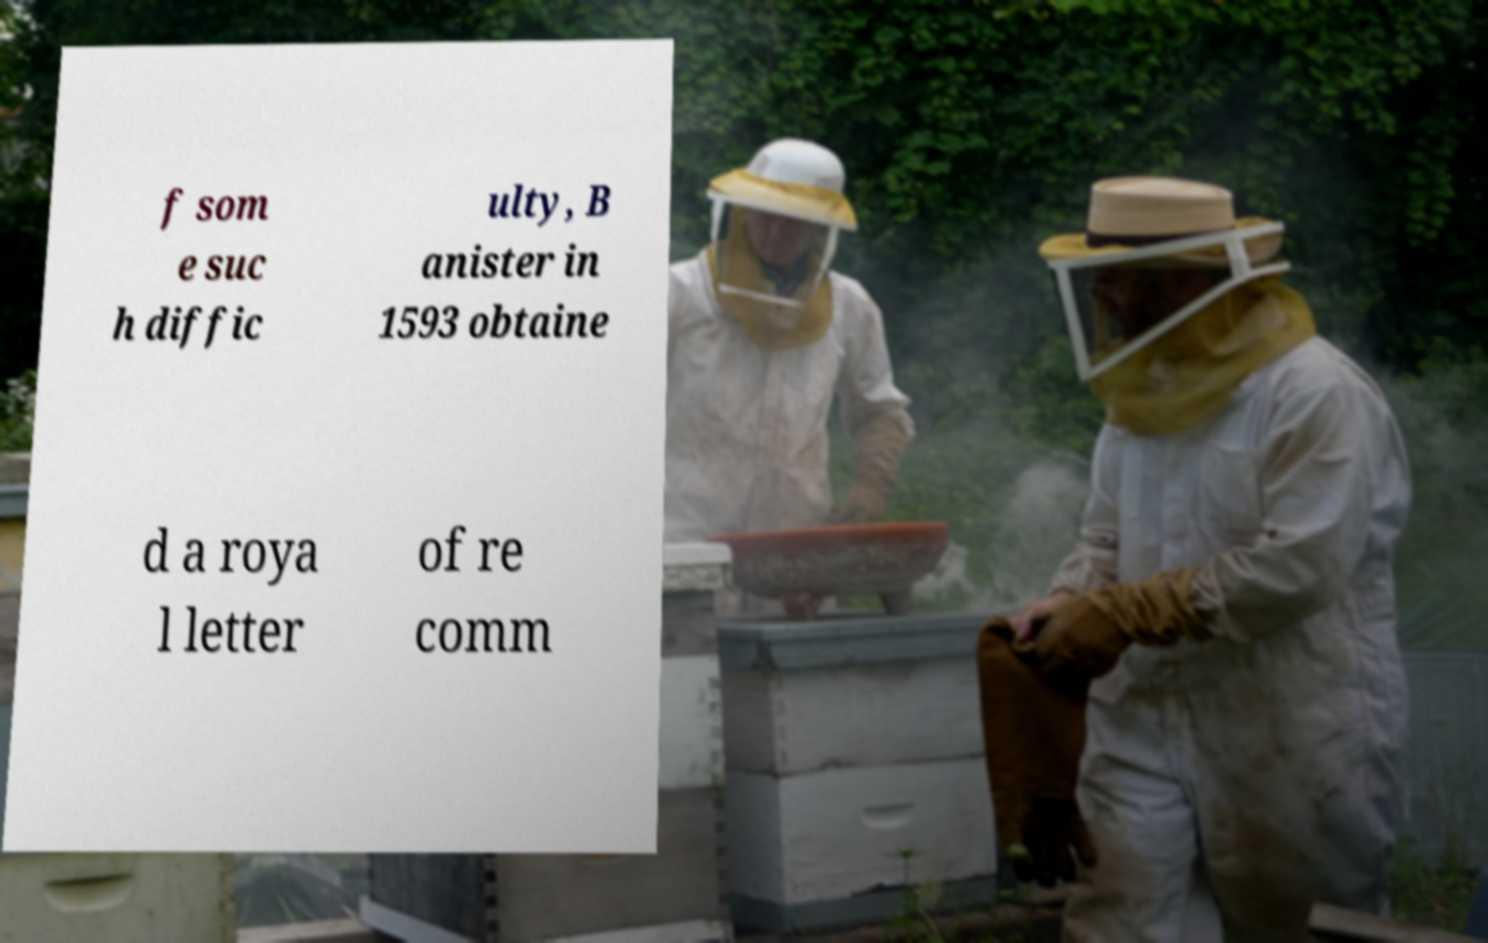There's text embedded in this image that I need extracted. Can you transcribe it verbatim? f som e suc h diffic ulty, B anister in 1593 obtaine d a roya l letter of re comm 